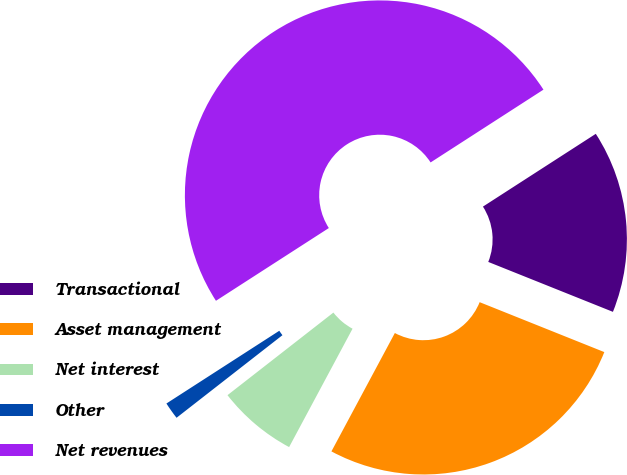Convert chart to OTSL. <chart><loc_0><loc_0><loc_500><loc_500><pie_chart><fcel>Transactional<fcel>Asset management<fcel>Net interest<fcel>Other<fcel>Net revenues<nl><fcel>15.18%<fcel>26.77%<fcel>6.63%<fcel>1.43%<fcel>50.0%<nl></chart> 